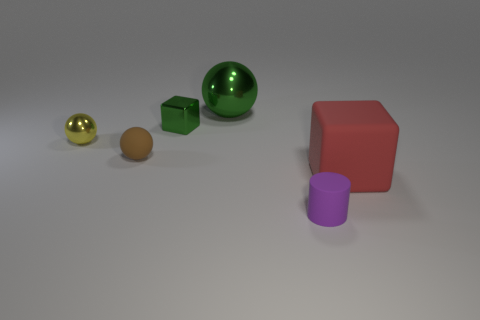There is a shiny thing that is the same color as the large metal sphere; what is its size?
Offer a very short reply. Small. There is a green object in front of the sphere that is behind the yellow thing; what size is it?
Your response must be concise. Small. Is the number of small metallic blocks that are in front of the red matte object greater than the number of large blue metal cylinders?
Offer a very short reply. No. There is a ball that is in front of the yellow shiny thing; is it the same size as the tiny green object?
Your response must be concise. Yes. There is a small object that is both to the right of the brown rubber object and behind the small brown rubber object; what color is it?
Your response must be concise. Green. What shape is the purple rubber thing that is the same size as the yellow metal ball?
Your answer should be very brief. Cylinder. Are there any other tiny rubber cylinders that have the same color as the cylinder?
Provide a short and direct response. No. Are there the same number of yellow spheres that are right of the green metal ball and things?
Offer a terse response. No. Does the large sphere have the same color as the matte sphere?
Offer a very short reply. No. What is the size of the matte thing that is behind the cylinder and left of the matte block?
Provide a short and direct response. Small. 